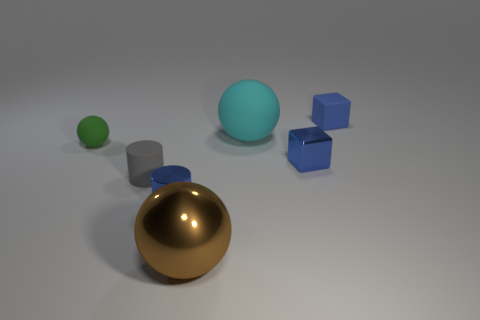Subtract all large spheres. How many spheres are left? 1 Subtract 1 spheres. How many spheres are left? 2 Add 2 big purple cylinders. How many objects exist? 9 Subtract all gray cylinders. How many cylinders are left? 1 Subtract all big blue rubber things. Subtract all small gray matte things. How many objects are left? 6 Add 2 matte spheres. How many matte spheres are left? 4 Add 7 small blue cubes. How many small blue cubes exist? 9 Subtract 0 purple spheres. How many objects are left? 7 Subtract all cubes. How many objects are left? 5 Subtract all red blocks. Subtract all red cylinders. How many blocks are left? 2 